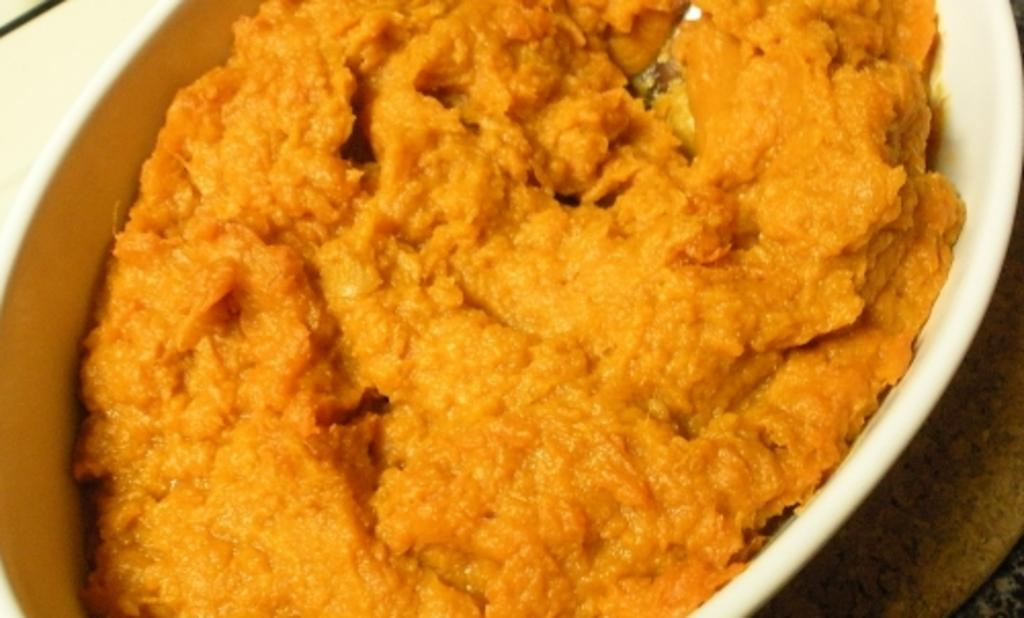What type of object is present in the image? There is an edible in the image. How is the edible contained or packaged? The edible is placed in a white box. How many wings are visible on the edible in the image? There are no wings visible on the edible in the image, as it is not a living creature. 